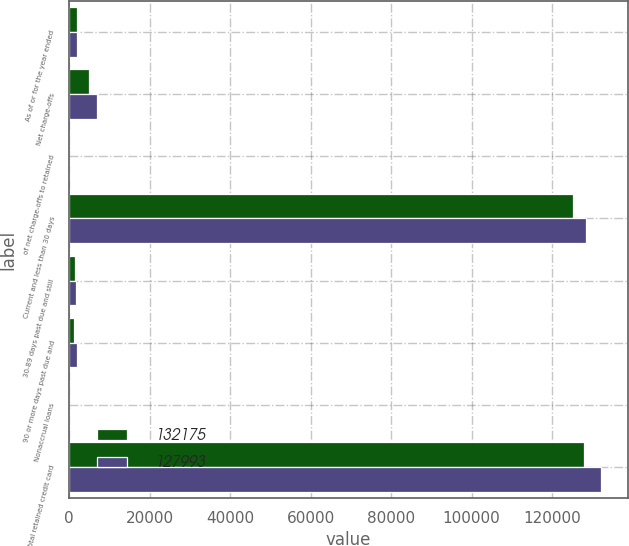<chart> <loc_0><loc_0><loc_500><loc_500><stacked_bar_chart><ecel><fcel>As of or for the year ended<fcel>Net charge-offs<fcel>of net charge-offs to retained<fcel>Current and less than 30 days<fcel>30-89 days past due and still<fcel>90 or more days past due and<fcel>Nonaccrual loans<fcel>Total retained credit card<nl><fcel>132175<fcel>2012<fcel>4944<fcel>3.95<fcel>125309<fcel>1381<fcel>1302<fcel>1<fcel>127993<nl><fcel>127993<fcel>2011<fcel>6925<fcel>5.44<fcel>128464<fcel>1808<fcel>1902<fcel>1<fcel>132175<nl></chart> 